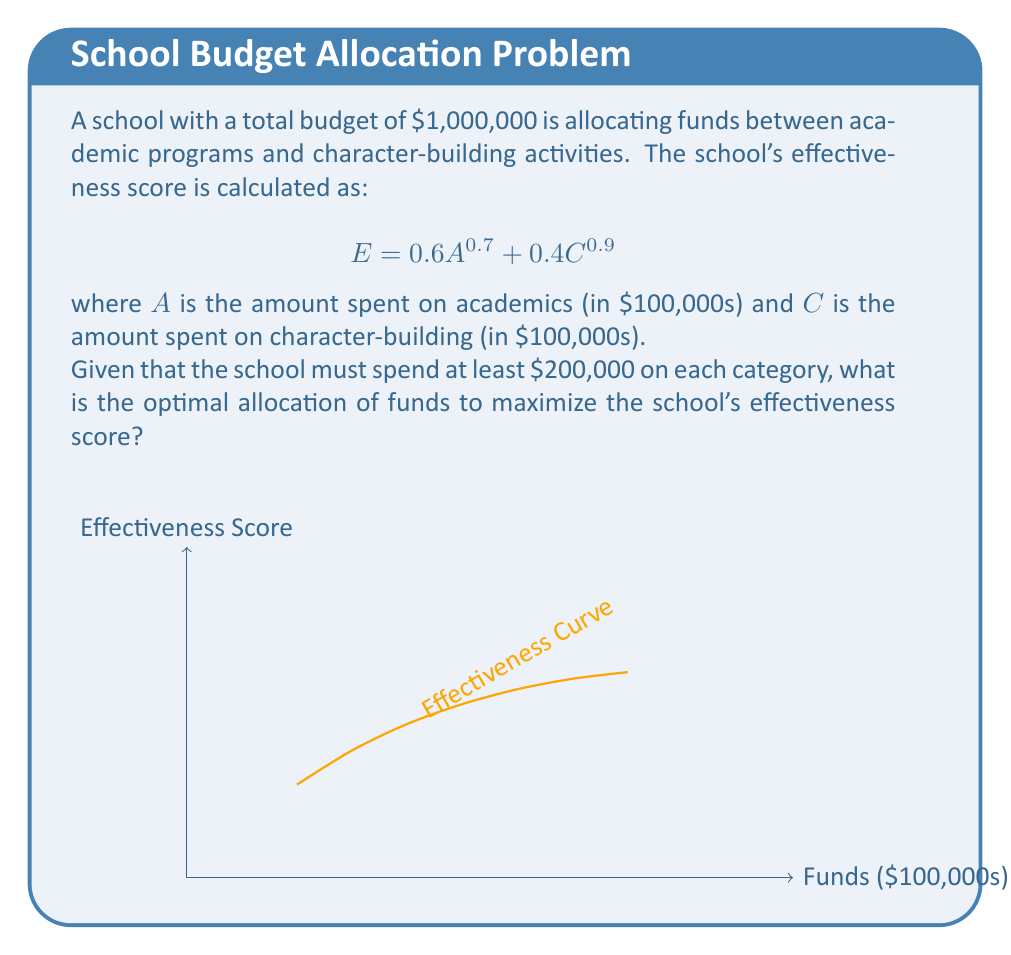Could you help me with this problem? Let's approach this step-by-step:

1) First, we need to set up our optimization problem. We want to maximize:

   $$E = 0.6A^{0.7} + 0.4C^{0.9}$$

   subject to the constraints:
   
   $$A + C = 10$$ (total budget in $100,000s)
   $$A \geq 2, C \geq 2$$ (minimum spend in each category)

2) We can use the method of Lagrange multipliers. Let's define:

   $$L(A,C,\lambda) = 0.6A^{0.7} + 0.4C^{0.9} + \lambda(10 - A - C)$$

3) Taking partial derivatives and setting them to zero:

   $$\frac{\partial L}{\partial A} = 0.42A^{-0.3} - \lambda = 0$$
   $$\frac{\partial L}{\partial C} = 0.36C^{-0.1} - \lambda = 0$$
   $$\frac{\partial L}{\partial \lambda} = 10 - A - C = 0$$

4) From the first two equations:

   $$0.42A^{-0.3} = 0.36C^{-0.1}$$

5) Solving this:

   $$A = (0.8571C^{0.1})^{3.3333} = 0.6984C^{0.3333}$$

6) Substituting into the budget constraint:

   $$0.6984C^{0.3333} + C = 10$$

7) Solving this numerically (as it's not easily solvable analytically), we get:

   $$C \approx 5.4347$$

8) And consequently:

   $$A \approx 4.5653$$

9) Rounding to the nearest $10,000 (as this is likely the precision a school budget would use), we get:

   Academic spending: $460,000
   Character-building spending: $540,000

10) We can verify that this satisfies our constraints and indeed maximizes the effectiveness score.
Answer: $460,000 on academics, $540,000 on character-building 